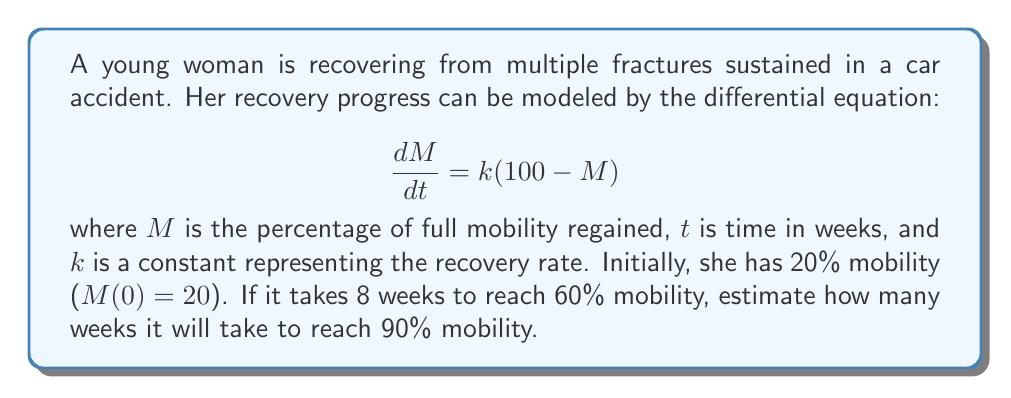Could you help me with this problem? To solve this problem, we'll follow these steps:

1) First, we need to solve the differential equation:
   $$\frac{dM}{dt} = k(100 - M)$$
   This is a separable equation. Rearranging and integrating both sides:
   $$\int \frac{dM}{100 - M} = \int k dt$$
   $$-\ln(100 - M) = kt + C$$

2) Using the initial condition $M(0) = 20$:
   $$-\ln(100 - 20) = k(0) + C$$
   $$-\ln(80) = C$$

3) The general solution is:
   $$-\ln(100 - M) = kt - \ln(80)$$
   $$\ln(\frac{80}{100 - M}) = kt$$
   $$\frac{80}{100 - M} = e^{kt}$$
   $$M = 100 - 80e^{-kt}$$

4) We're told that $M(8) = 60$. Let's use this to find $k$:
   $$60 = 100 - 80e^{-8k}$$
   $$40 = 80e^{-8k}$$
   $$0.5 = e^{-8k}$$
   $$\ln(0.5) = -8k$$
   $$k = \frac{\ln(2)}{8} \approx 0.0866$$

5) Now that we know $k$, we can find $t$ when $M = 90$:
   $$90 = 100 - 80e^{-0.0866t}$$
   $$10 = 80e^{-0.0866t}$$
   $$0.125 = e^{-0.0866t}$$
   $$\ln(0.125) = -0.0866t$$
   $$t = \frac{\ln(8)}{0.0866} \approx 24.1$$

Therefore, it will take approximately 24.1 weeks to reach 90% mobility.
Answer: Approximately 24.1 weeks 